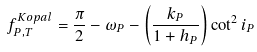Convert formula to latex. <formula><loc_0><loc_0><loc_500><loc_500>f _ { P , T } ^ { K o p a l } = \frac { \pi } { 2 } - \omega _ { P } - \left ( \frac { k _ { P } } { 1 + h _ { P } } \right ) \cot ^ { 2 } i _ { P }</formula> 